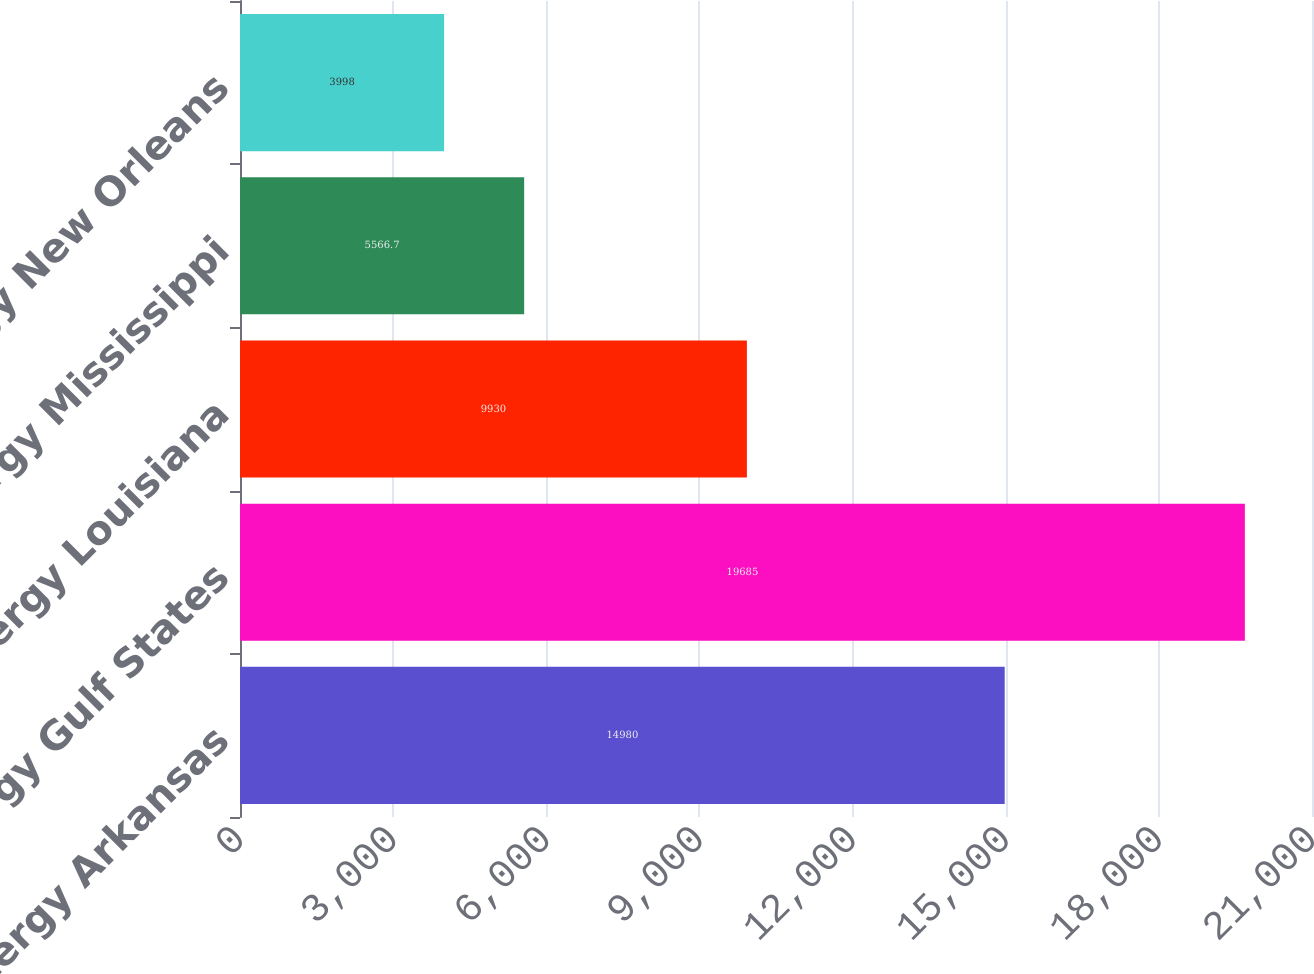<chart> <loc_0><loc_0><loc_500><loc_500><bar_chart><fcel>Entergy Arkansas<fcel>Entergy Gulf States<fcel>Entergy Louisiana<fcel>Entergy Mississippi<fcel>Entergy New Orleans<nl><fcel>14980<fcel>19685<fcel>9930<fcel>5566.7<fcel>3998<nl></chart> 